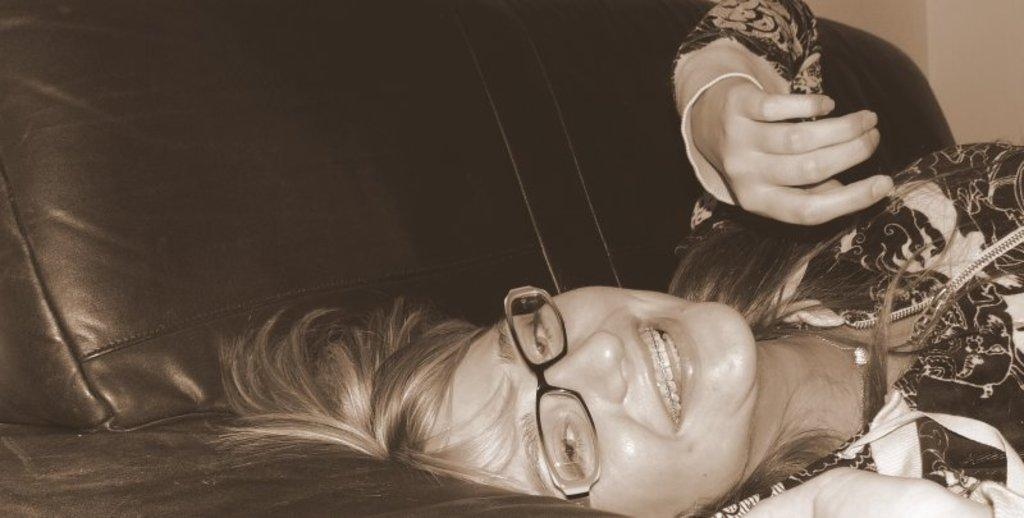What is the color scheme of the image? The image is black and white. Can you describe the person in the image? The person in the image is wearing spectacles. What is the person doing in the image? The person is lying on a sofa. What can be seen in the background of the image? There is a wall visible in the image. What type of insect is sitting on the person's shoulder in the image? There is no insect present on the person's shoulder in the image. Who is the queen in the image? There is no queen depicted in the image. 